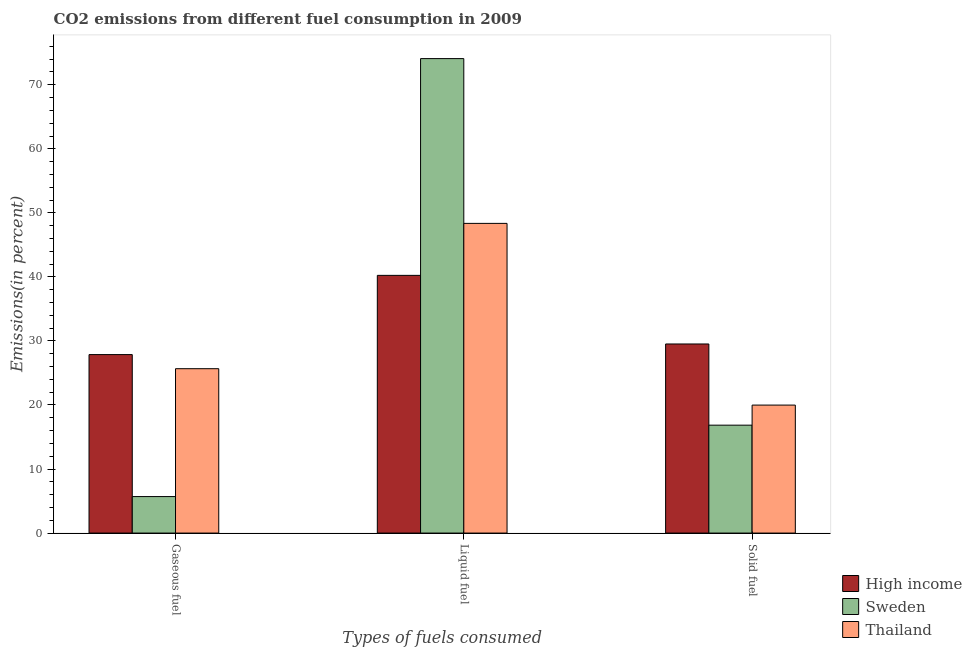How many different coloured bars are there?
Ensure brevity in your answer.  3. How many groups of bars are there?
Your answer should be very brief. 3. Are the number of bars on each tick of the X-axis equal?
Your response must be concise. Yes. How many bars are there on the 3rd tick from the left?
Your answer should be very brief. 3. What is the label of the 3rd group of bars from the left?
Ensure brevity in your answer.  Solid fuel. What is the percentage of liquid fuel emission in High income?
Offer a very short reply. 40.24. Across all countries, what is the maximum percentage of solid fuel emission?
Offer a terse response. 29.53. Across all countries, what is the minimum percentage of solid fuel emission?
Keep it short and to the point. 16.85. In which country was the percentage of gaseous fuel emission maximum?
Provide a succinct answer. High income. In which country was the percentage of solid fuel emission minimum?
Provide a short and direct response. Sweden. What is the total percentage of liquid fuel emission in the graph?
Your response must be concise. 162.69. What is the difference between the percentage of solid fuel emission in Sweden and that in High income?
Give a very brief answer. -12.68. What is the difference between the percentage of gaseous fuel emission in High income and the percentage of liquid fuel emission in Thailand?
Give a very brief answer. -20.49. What is the average percentage of liquid fuel emission per country?
Offer a very short reply. 54.23. What is the difference between the percentage of liquid fuel emission and percentage of solid fuel emission in Thailand?
Give a very brief answer. 28.37. What is the ratio of the percentage of liquid fuel emission in Sweden to that in High income?
Offer a very short reply. 1.84. What is the difference between the highest and the second highest percentage of solid fuel emission?
Offer a very short reply. 9.54. What is the difference between the highest and the lowest percentage of gaseous fuel emission?
Your answer should be compact. 22.17. What does the 2nd bar from the left in Liquid fuel represents?
Give a very brief answer. Sweden. What does the 3rd bar from the right in Solid fuel represents?
Your answer should be compact. High income. Are all the bars in the graph horizontal?
Make the answer very short. No. How many countries are there in the graph?
Your answer should be compact. 3. What is the difference between two consecutive major ticks on the Y-axis?
Ensure brevity in your answer.  10. Are the values on the major ticks of Y-axis written in scientific E-notation?
Provide a succinct answer. No. Where does the legend appear in the graph?
Offer a very short reply. Bottom right. How many legend labels are there?
Your answer should be very brief. 3. What is the title of the graph?
Make the answer very short. CO2 emissions from different fuel consumption in 2009. What is the label or title of the X-axis?
Offer a very short reply. Types of fuels consumed. What is the label or title of the Y-axis?
Your answer should be very brief. Emissions(in percent). What is the Emissions(in percent) in High income in Gaseous fuel?
Ensure brevity in your answer.  27.87. What is the Emissions(in percent) of Sweden in Gaseous fuel?
Make the answer very short. 5.7. What is the Emissions(in percent) of Thailand in Gaseous fuel?
Give a very brief answer. 25.67. What is the Emissions(in percent) in High income in Liquid fuel?
Your answer should be compact. 40.24. What is the Emissions(in percent) of Sweden in Liquid fuel?
Offer a very short reply. 74.09. What is the Emissions(in percent) of Thailand in Liquid fuel?
Provide a succinct answer. 48.36. What is the Emissions(in percent) in High income in Solid fuel?
Provide a short and direct response. 29.53. What is the Emissions(in percent) in Sweden in Solid fuel?
Provide a short and direct response. 16.85. What is the Emissions(in percent) of Thailand in Solid fuel?
Give a very brief answer. 19.98. Across all Types of fuels consumed, what is the maximum Emissions(in percent) in High income?
Your response must be concise. 40.24. Across all Types of fuels consumed, what is the maximum Emissions(in percent) in Sweden?
Provide a succinct answer. 74.09. Across all Types of fuels consumed, what is the maximum Emissions(in percent) of Thailand?
Give a very brief answer. 48.36. Across all Types of fuels consumed, what is the minimum Emissions(in percent) in High income?
Ensure brevity in your answer.  27.87. Across all Types of fuels consumed, what is the minimum Emissions(in percent) of Sweden?
Your response must be concise. 5.7. Across all Types of fuels consumed, what is the minimum Emissions(in percent) in Thailand?
Provide a short and direct response. 19.98. What is the total Emissions(in percent) in High income in the graph?
Your answer should be compact. 97.64. What is the total Emissions(in percent) of Sweden in the graph?
Make the answer very short. 96.64. What is the total Emissions(in percent) in Thailand in the graph?
Your answer should be very brief. 94.01. What is the difference between the Emissions(in percent) of High income in Gaseous fuel and that in Liquid fuel?
Offer a terse response. -12.37. What is the difference between the Emissions(in percent) of Sweden in Gaseous fuel and that in Liquid fuel?
Offer a terse response. -68.39. What is the difference between the Emissions(in percent) in Thailand in Gaseous fuel and that in Liquid fuel?
Provide a short and direct response. -22.69. What is the difference between the Emissions(in percent) in High income in Gaseous fuel and that in Solid fuel?
Offer a very short reply. -1.66. What is the difference between the Emissions(in percent) of Sweden in Gaseous fuel and that in Solid fuel?
Offer a terse response. -11.15. What is the difference between the Emissions(in percent) in Thailand in Gaseous fuel and that in Solid fuel?
Your answer should be very brief. 5.68. What is the difference between the Emissions(in percent) of High income in Liquid fuel and that in Solid fuel?
Your answer should be very brief. 10.71. What is the difference between the Emissions(in percent) in Sweden in Liquid fuel and that in Solid fuel?
Your response must be concise. 57.24. What is the difference between the Emissions(in percent) in Thailand in Liquid fuel and that in Solid fuel?
Your answer should be compact. 28.37. What is the difference between the Emissions(in percent) in High income in Gaseous fuel and the Emissions(in percent) in Sweden in Liquid fuel?
Offer a very short reply. -46.22. What is the difference between the Emissions(in percent) in High income in Gaseous fuel and the Emissions(in percent) in Thailand in Liquid fuel?
Offer a terse response. -20.49. What is the difference between the Emissions(in percent) in Sweden in Gaseous fuel and the Emissions(in percent) in Thailand in Liquid fuel?
Provide a succinct answer. -42.66. What is the difference between the Emissions(in percent) of High income in Gaseous fuel and the Emissions(in percent) of Sweden in Solid fuel?
Make the answer very short. 11.02. What is the difference between the Emissions(in percent) in High income in Gaseous fuel and the Emissions(in percent) in Thailand in Solid fuel?
Your answer should be very brief. 7.89. What is the difference between the Emissions(in percent) in Sweden in Gaseous fuel and the Emissions(in percent) in Thailand in Solid fuel?
Offer a very short reply. -14.28. What is the difference between the Emissions(in percent) in High income in Liquid fuel and the Emissions(in percent) in Sweden in Solid fuel?
Ensure brevity in your answer.  23.39. What is the difference between the Emissions(in percent) in High income in Liquid fuel and the Emissions(in percent) in Thailand in Solid fuel?
Your answer should be very brief. 20.26. What is the difference between the Emissions(in percent) in Sweden in Liquid fuel and the Emissions(in percent) in Thailand in Solid fuel?
Keep it short and to the point. 54.1. What is the average Emissions(in percent) in High income per Types of fuels consumed?
Offer a very short reply. 32.55. What is the average Emissions(in percent) of Sweden per Types of fuels consumed?
Your answer should be compact. 32.21. What is the average Emissions(in percent) of Thailand per Types of fuels consumed?
Keep it short and to the point. 31.34. What is the difference between the Emissions(in percent) of High income and Emissions(in percent) of Sweden in Gaseous fuel?
Offer a terse response. 22.17. What is the difference between the Emissions(in percent) of High income and Emissions(in percent) of Thailand in Gaseous fuel?
Your response must be concise. 2.2. What is the difference between the Emissions(in percent) of Sweden and Emissions(in percent) of Thailand in Gaseous fuel?
Your answer should be compact. -19.97. What is the difference between the Emissions(in percent) of High income and Emissions(in percent) of Sweden in Liquid fuel?
Provide a short and direct response. -33.85. What is the difference between the Emissions(in percent) in High income and Emissions(in percent) in Thailand in Liquid fuel?
Offer a terse response. -8.12. What is the difference between the Emissions(in percent) in Sweden and Emissions(in percent) in Thailand in Liquid fuel?
Make the answer very short. 25.73. What is the difference between the Emissions(in percent) of High income and Emissions(in percent) of Sweden in Solid fuel?
Provide a short and direct response. 12.68. What is the difference between the Emissions(in percent) of High income and Emissions(in percent) of Thailand in Solid fuel?
Provide a short and direct response. 9.54. What is the difference between the Emissions(in percent) in Sweden and Emissions(in percent) in Thailand in Solid fuel?
Give a very brief answer. -3.13. What is the ratio of the Emissions(in percent) in High income in Gaseous fuel to that in Liquid fuel?
Offer a very short reply. 0.69. What is the ratio of the Emissions(in percent) of Sweden in Gaseous fuel to that in Liquid fuel?
Ensure brevity in your answer.  0.08. What is the ratio of the Emissions(in percent) of Thailand in Gaseous fuel to that in Liquid fuel?
Give a very brief answer. 0.53. What is the ratio of the Emissions(in percent) of High income in Gaseous fuel to that in Solid fuel?
Your response must be concise. 0.94. What is the ratio of the Emissions(in percent) in Sweden in Gaseous fuel to that in Solid fuel?
Your answer should be compact. 0.34. What is the ratio of the Emissions(in percent) in Thailand in Gaseous fuel to that in Solid fuel?
Ensure brevity in your answer.  1.28. What is the ratio of the Emissions(in percent) in High income in Liquid fuel to that in Solid fuel?
Make the answer very short. 1.36. What is the ratio of the Emissions(in percent) of Sweden in Liquid fuel to that in Solid fuel?
Offer a terse response. 4.4. What is the ratio of the Emissions(in percent) in Thailand in Liquid fuel to that in Solid fuel?
Give a very brief answer. 2.42. What is the difference between the highest and the second highest Emissions(in percent) of High income?
Ensure brevity in your answer.  10.71. What is the difference between the highest and the second highest Emissions(in percent) in Sweden?
Provide a short and direct response. 57.24. What is the difference between the highest and the second highest Emissions(in percent) in Thailand?
Make the answer very short. 22.69. What is the difference between the highest and the lowest Emissions(in percent) of High income?
Offer a terse response. 12.37. What is the difference between the highest and the lowest Emissions(in percent) of Sweden?
Provide a short and direct response. 68.39. What is the difference between the highest and the lowest Emissions(in percent) in Thailand?
Ensure brevity in your answer.  28.37. 